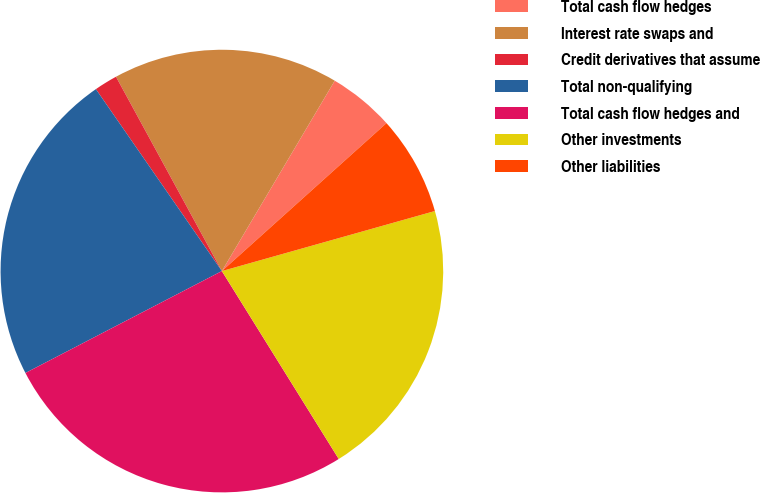Convert chart to OTSL. <chart><loc_0><loc_0><loc_500><loc_500><pie_chart><fcel>Total cash flow hedges<fcel>Interest rate swaps and<fcel>Credit derivatives that assume<fcel>Total non-qualifying<fcel>Total cash flow hedges and<fcel>Other investments<fcel>Other liabilities<nl><fcel>4.83%<fcel>16.46%<fcel>1.7%<fcel>22.98%<fcel>26.24%<fcel>20.52%<fcel>7.28%<nl></chart> 